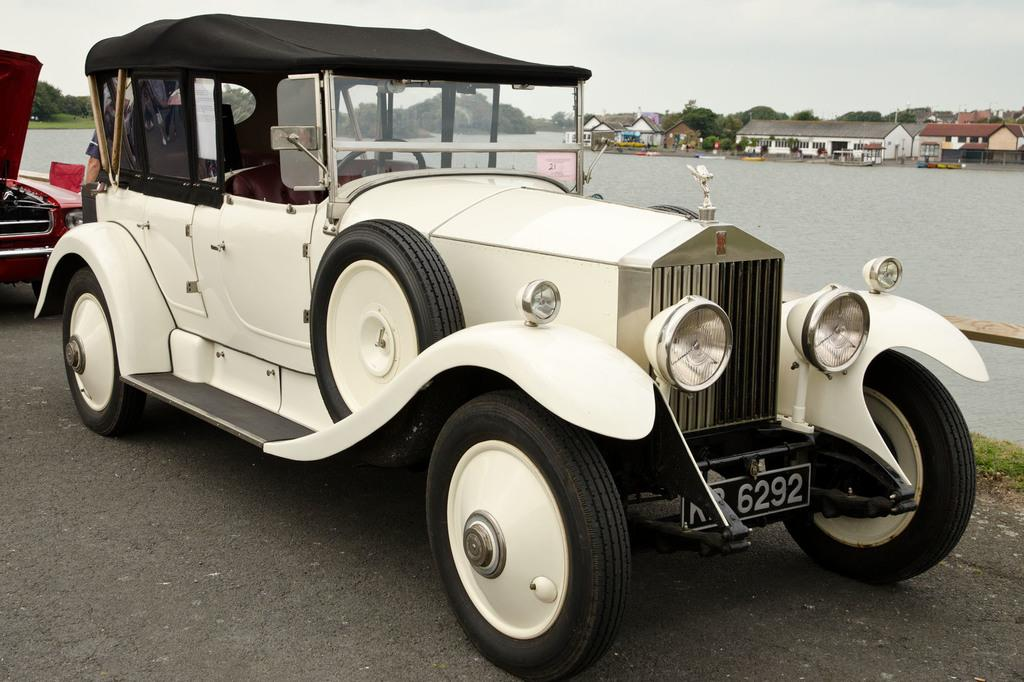What can be seen in the image that is used for transportation? There are vehicles in the image that are used for transportation. What is happening on the road in the image? There is a person on the road in the image. What body of water is visible in the image? There is a lake visible in the image. What structures can be seen on the other side of the lake? There are houses on the other side of the lake in the image. What type of vegetation is present in the image? Trees are present in the image. What type of beef is being served on the stage in the image? There is no beef or stage present in the image. What color is the person's lip in the image? The provided facts do not mention the color of the person's lip, and it cannot be determined from the image. 